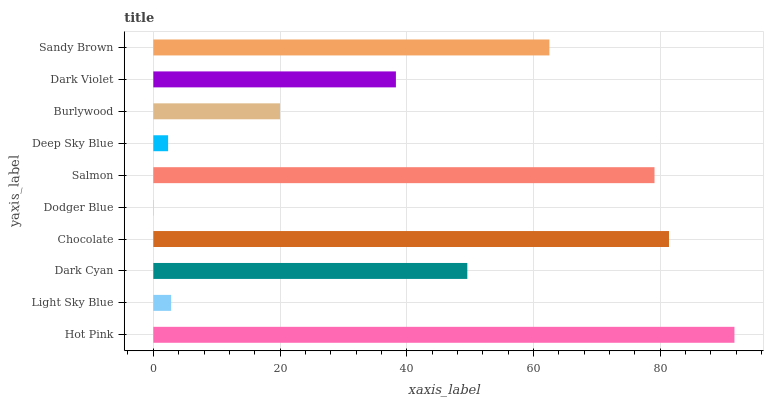Is Dodger Blue the minimum?
Answer yes or no. Yes. Is Hot Pink the maximum?
Answer yes or no. Yes. Is Light Sky Blue the minimum?
Answer yes or no. No. Is Light Sky Blue the maximum?
Answer yes or no. No. Is Hot Pink greater than Light Sky Blue?
Answer yes or no. Yes. Is Light Sky Blue less than Hot Pink?
Answer yes or no. Yes. Is Light Sky Blue greater than Hot Pink?
Answer yes or no. No. Is Hot Pink less than Light Sky Blue?
Answer yes or no. No. Is Dark Cyan the high median?
Answer yes or no. Yes. Is Dark Violet the low median?
Answer yes or no. Yes. Is Dark Violet the high median?
Answer yes or no. No. Is Chocolate the low median?
Answer yes or no. No. 